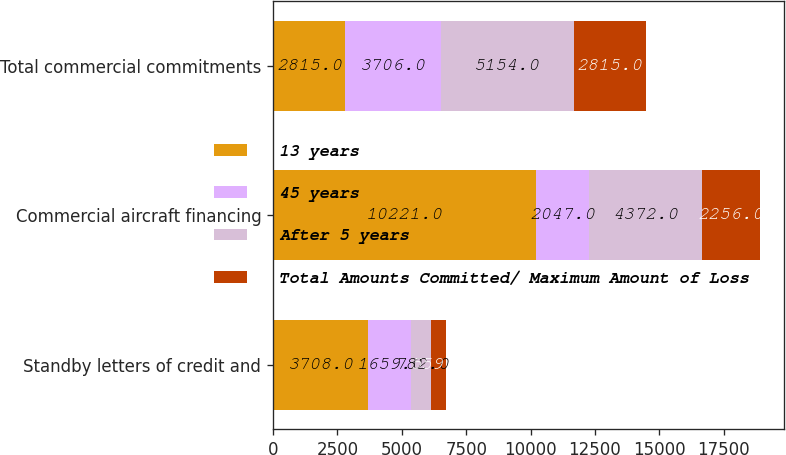Convert chart. <chart><loc_0><loc_0><loc_500><loc_500><stacked_bar_chart><ecel><fcel>Standby letters of credit and<fcel>Commercial aircraft financing<fcel>Total commercial commitments<nl><fcel>13 years<fcel>3708<fcel>10221<fcel>2815<nl><fcel>45 years<fcel>1659<fcel>2047<fcel>3706<nl><fcel>After 5 years<fcel>782<fcel>4372<fcel>5154<nl><fcel>Total Amounts Committed/ Maximum Amount of Loss<fcel>559<fcel>2256<fcel>2815<nl></chart> 